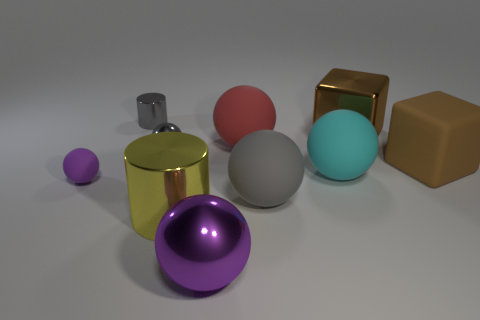Subtract all gray spheres. How many spheres are left? 4 Subtract all big cyan balls. How many balls are left? 5 Subtract all gray spheres. Subtract all purple blocks. How many spheres are left? 4 Subtract all balls. How many objects are left? 4 Subtract all tiny gray metallic cylinders. Subtract all metallic cubes. How many objects are left? 8 Add 2 big purple things. How many big purple things are left? 3 Add 1 large cubes. How many large cubes exist? 3 Subtract 0 purple cylinders. How many objects are left? 10 